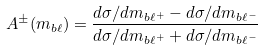<formula> <loc_0><loc_0><loc_500><loc_500>A ^ { \pm } ( m _ { b \ell } ) = \frac { d \sigma / d m _ { b \ell ^ { + } } - d \sigma / d m _ { b \ell ^ { - } } } { d \sigma / d m _ { b \ell ^ { + } } + d \sigma / d m _ { b \ell ^ { - } } }</formula> 